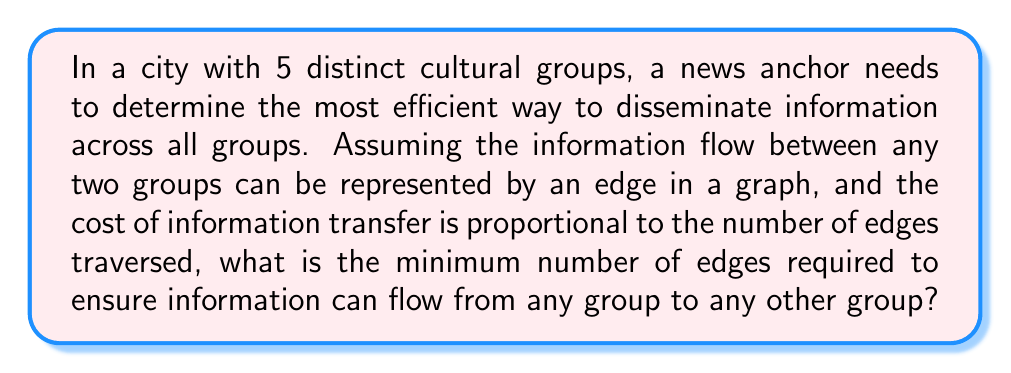Provide a solution to this math problem. This problem can be approached using concepts from graph theory and topology. Let's break it down step-by-step:

1) We have 5 cultural groups, which we can represent as vertices in a graph.

2) The goal is to connect these vertices (groups) in a way that allows information to flow between any two groups, while minimizing the number of edges (connections).

3) This scenario describes a minimum spanning tree problem in graph theory.

4) For a graph with $n$ vertices, the minimum number of edges required to connect all vertices (ensuring all are reachable from any other) is $n-1$.

5) In this case, we have $n = 5$ cultural groups.

6) Therefore, the minimum number of edges required is:

   $$5 - 1 = 4$$

7) This configuration ensures that information can flow from any group to any other group, possibly through intermediary groups, while minimizing the total number of direct connections.

8) The resulting graph would resemble a tree structure, where each cultural group is connected to at least one other group, and there are no cycles in the graph.

[asy]
unitsize(1cm);

pair A = (0,0);
pair B = (2,0);
pair C = (1,1.732);
pair D = (-1,1);
pair E = (3,1);

draw(A--B--C--D--A);
draw(B--E);

dot(A);
dot(B);
dot(C);
dot(D);
dot(E);

label("A", A, SW);
label("B", B, SE);
label("C", C, N);
label("D", D, NW);
label("E", E, NE);
[/asy]

In this diagram, A, B, C, D, and E represent the five cultural groups, and the lines represent the four edges connecting them in a minimum spanning tree configuration.
Answer: The minimum number of edges required is 4. 